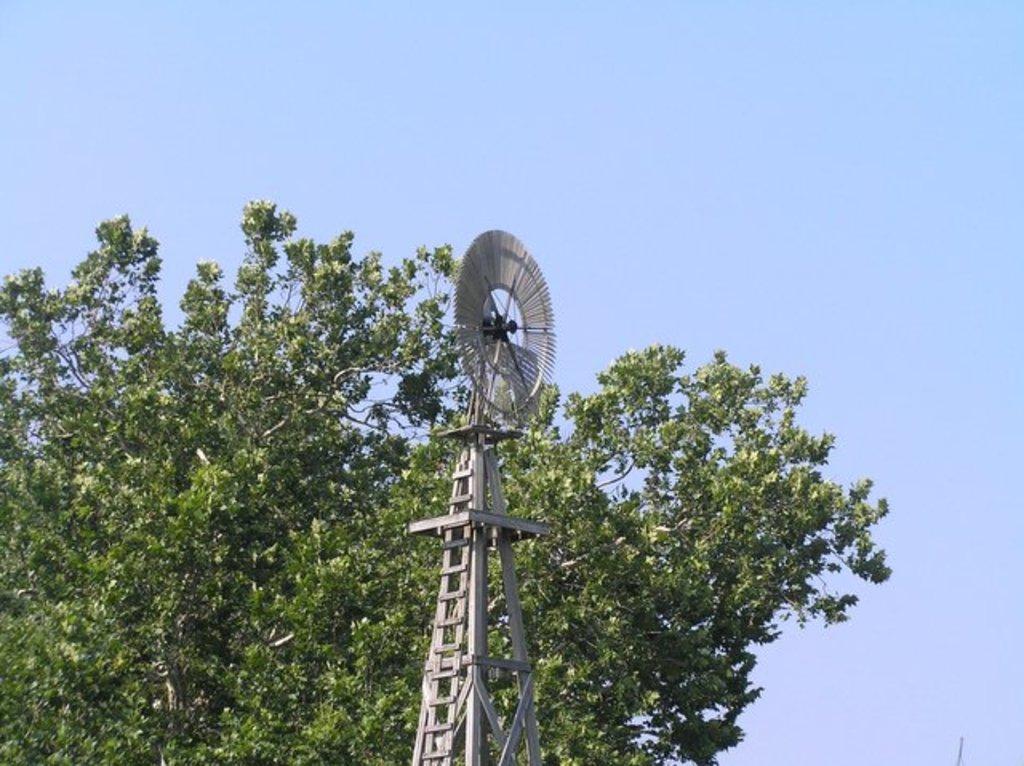Please provide a concise description of this image. In the center of the image we can see tower and tree. In the background there is sky. 